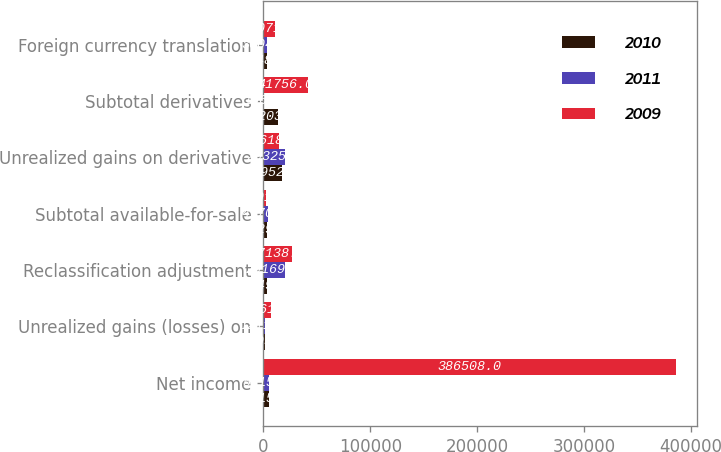<chart> <loc_0><loc_0><loc_500><loc_500><stacked_bar_chart><ecel><fcel>Net income<fcel>Unrealized gains (losses) on<fcel>Reclassification adjustment<fcel>Subtotal available-for-sale<fcel>Unrealized gains on derivative<fcel>Subtotal derivatives<fcel>Foreign currency translation<nl><fcel>2010<fcel>5415.5<fcel>1795<fcel>3749<fcel>3629<fcel>16952<fcel>13203<fcel>2948<nl><fcel>2011<fcel>5415.5<fcel>1211<fcel>20169<fcel>4170<fcel>20325<fcel>156<fcel>3004<nl><fcel>2009<fcel>386508<fcel>6661<fcel>27138<fcel>2091<fcel>14618<fcel>41756<fcel>11071<nl></chart> 